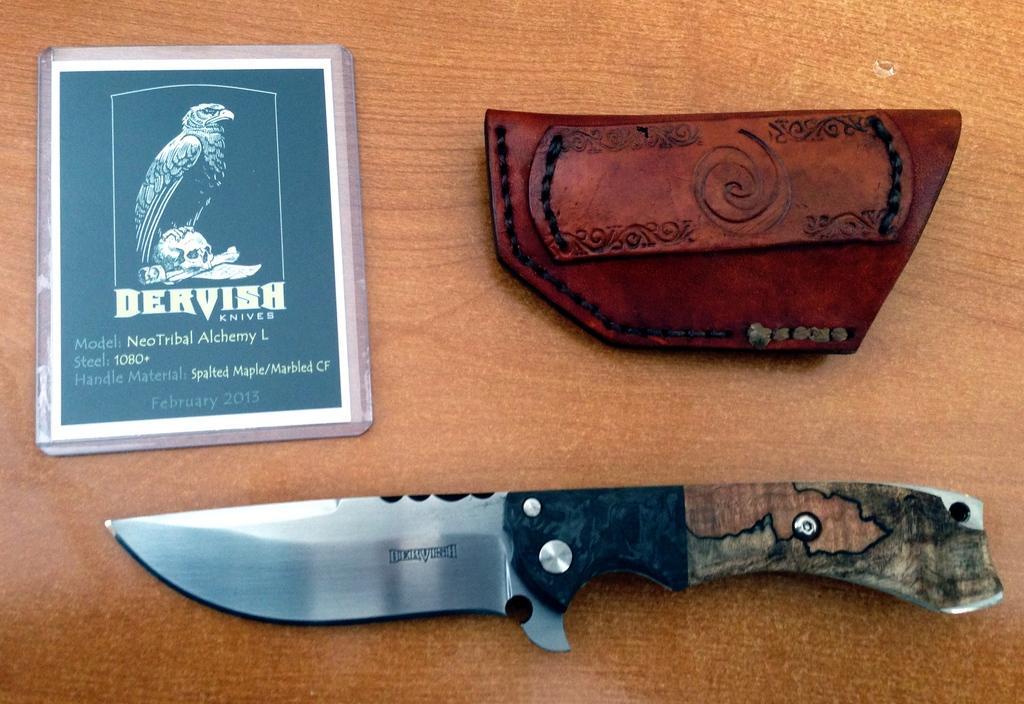Can you describe this image briefly? In this picture we can see a knife, a leather pouch and a laminated card kept on a wooden surface. 